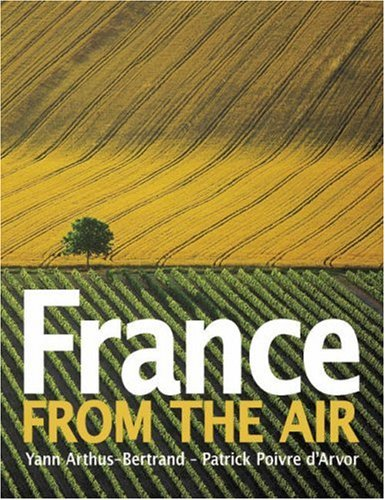Is this a sociopolitical book? No, this book does not delve into sociopolitical themes; instead, it focuses on the artistic and photographic depiction of geographical aesthetics. 